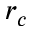Convert formula to latex. <formula><loc_0><loc_0><loc_500><loc_500>r _ { c }</formula> 